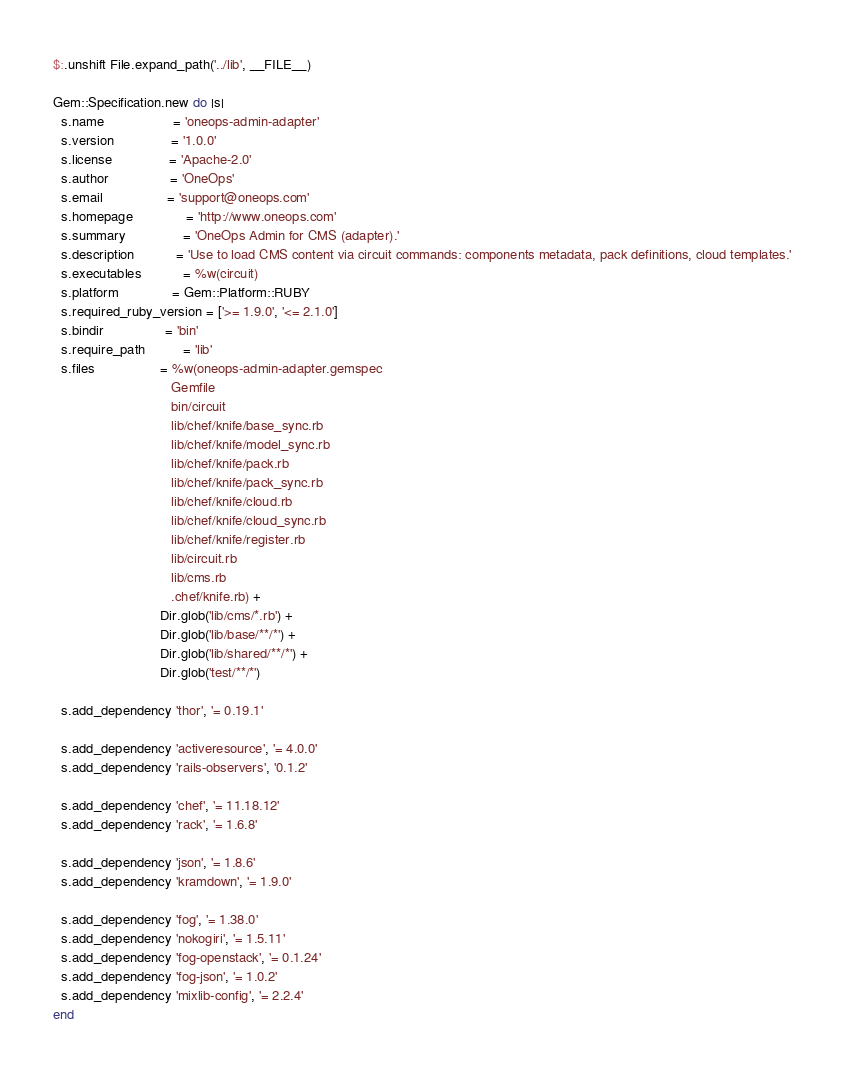<code> <loc_0><loc_0><loc_500><loc_500><_Ruby_>$:.unshift File.expand_path('../lib', __FILE__)

Gem::Specification.new do |s|
  s.name                  = 'oneops-admin-adapter'
  s.version               = '1.0.0'
  s.license               = 'Apache-2.0'
  s.author                = 'OneOps'
  s.email                 = 'support@oneops.com'
  s.homepage              = 'http://www.oneops.com'
  s.summary               = 'OneOps Admin for CMS (adapter).'
  s.description           = 'Use to load CMS content via circuit commands: components metadata, pack definitions, cloud templates.'
  s.executables           = %w(circuit)
  s.platform              = Gem::Platform::RUBY
  s.required_ruby_version = ['>= 1.9.0', '<= 2.1.0']
  s.bindir                = 'bin'
  s.require_path          = 'lib'
  s.files                 = %w(oneops-admin-adapter.gemspec
                               Gemfile
                               bin/circuit
                               lib/chef/knife/base_sync.rb
                               lib/chef/knife/model_sync.rb
                               lib/chef/knife/pack.rb
                               lib/chef/knife/pack_sync.rb
                               lib/chef/knife/cloud.rb
                               lib/chef/knife/cloud_sync.rb
                               lib/chef/knife/register.rb
                               lib/circuit.rb
                               lib/cms.rb
                               .chef/knife.rb) +
                            Dir.glob('lib/cms/*.rb') +
                            Dir.glob('lib/base/**/*') +
                            Dir.glob('lib/shared/**/*') +
                            Dir.glob('test/**/*')

  s.add_dependency 'thor', '= 0.19.1'

  s.add_dependency 'activeresource', '= 4.0.0'
  s.add_dependency 'rails-observers', '0.1.2'

  s.add_dependency 'chef', '= 11.18.12'
  s.add_dependency 'rack', '= 1.6.8'

  s.add_dependency 'json', '= 1.8.6'
  s.add_dependency 'kramdown', '= 1.9.0'

  s.add_dependency 'fog', '= 1.38.0'
  s.add_dependency 'nokogiri', '= 1.5.11'
  s.add_dependency 'fog-openstack', '= 0.1.24'
  s.add_dependency 'fog-json', '= 1.0.2'
  s.add_dependency 'mixlib-config', '= 2.2.4'
end
</code> 